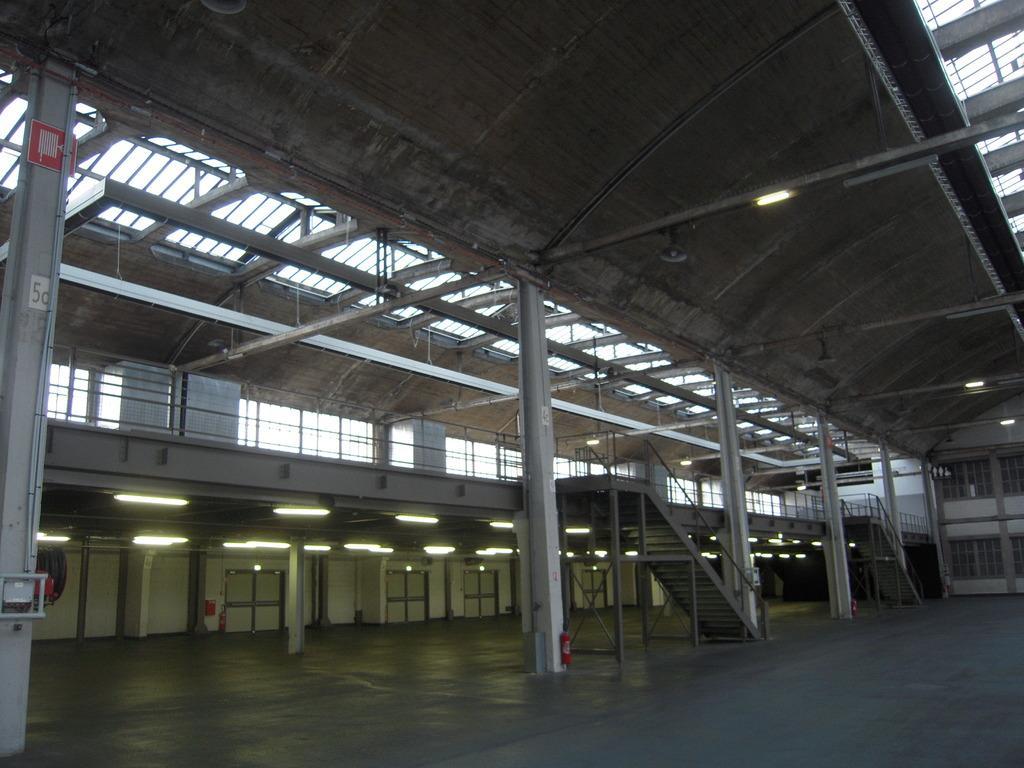Please provide a concise description of this image. In the center of the image we can see stairs, pillars, windows, doors and wall. 